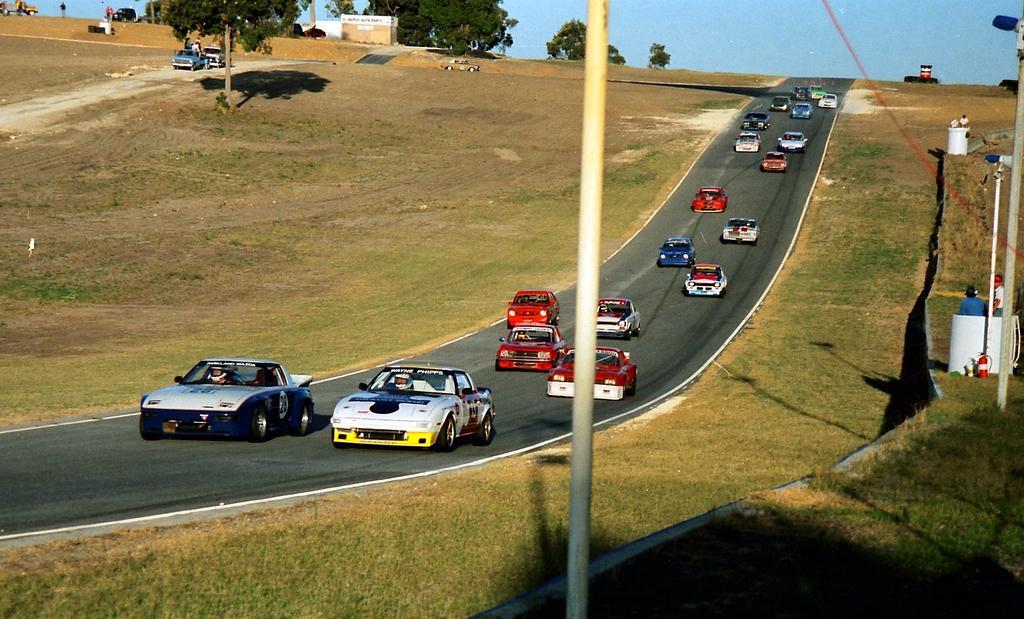Describe this image in one or two sentences. In this picture we can see many sports car on the road. On the right there are two person standing near to the white pole and traffic cone. On the top left we can see some peoples are standing near to their cars. Here we can see trees and house. On the bottom we can see grass. At the top we can see sky. 